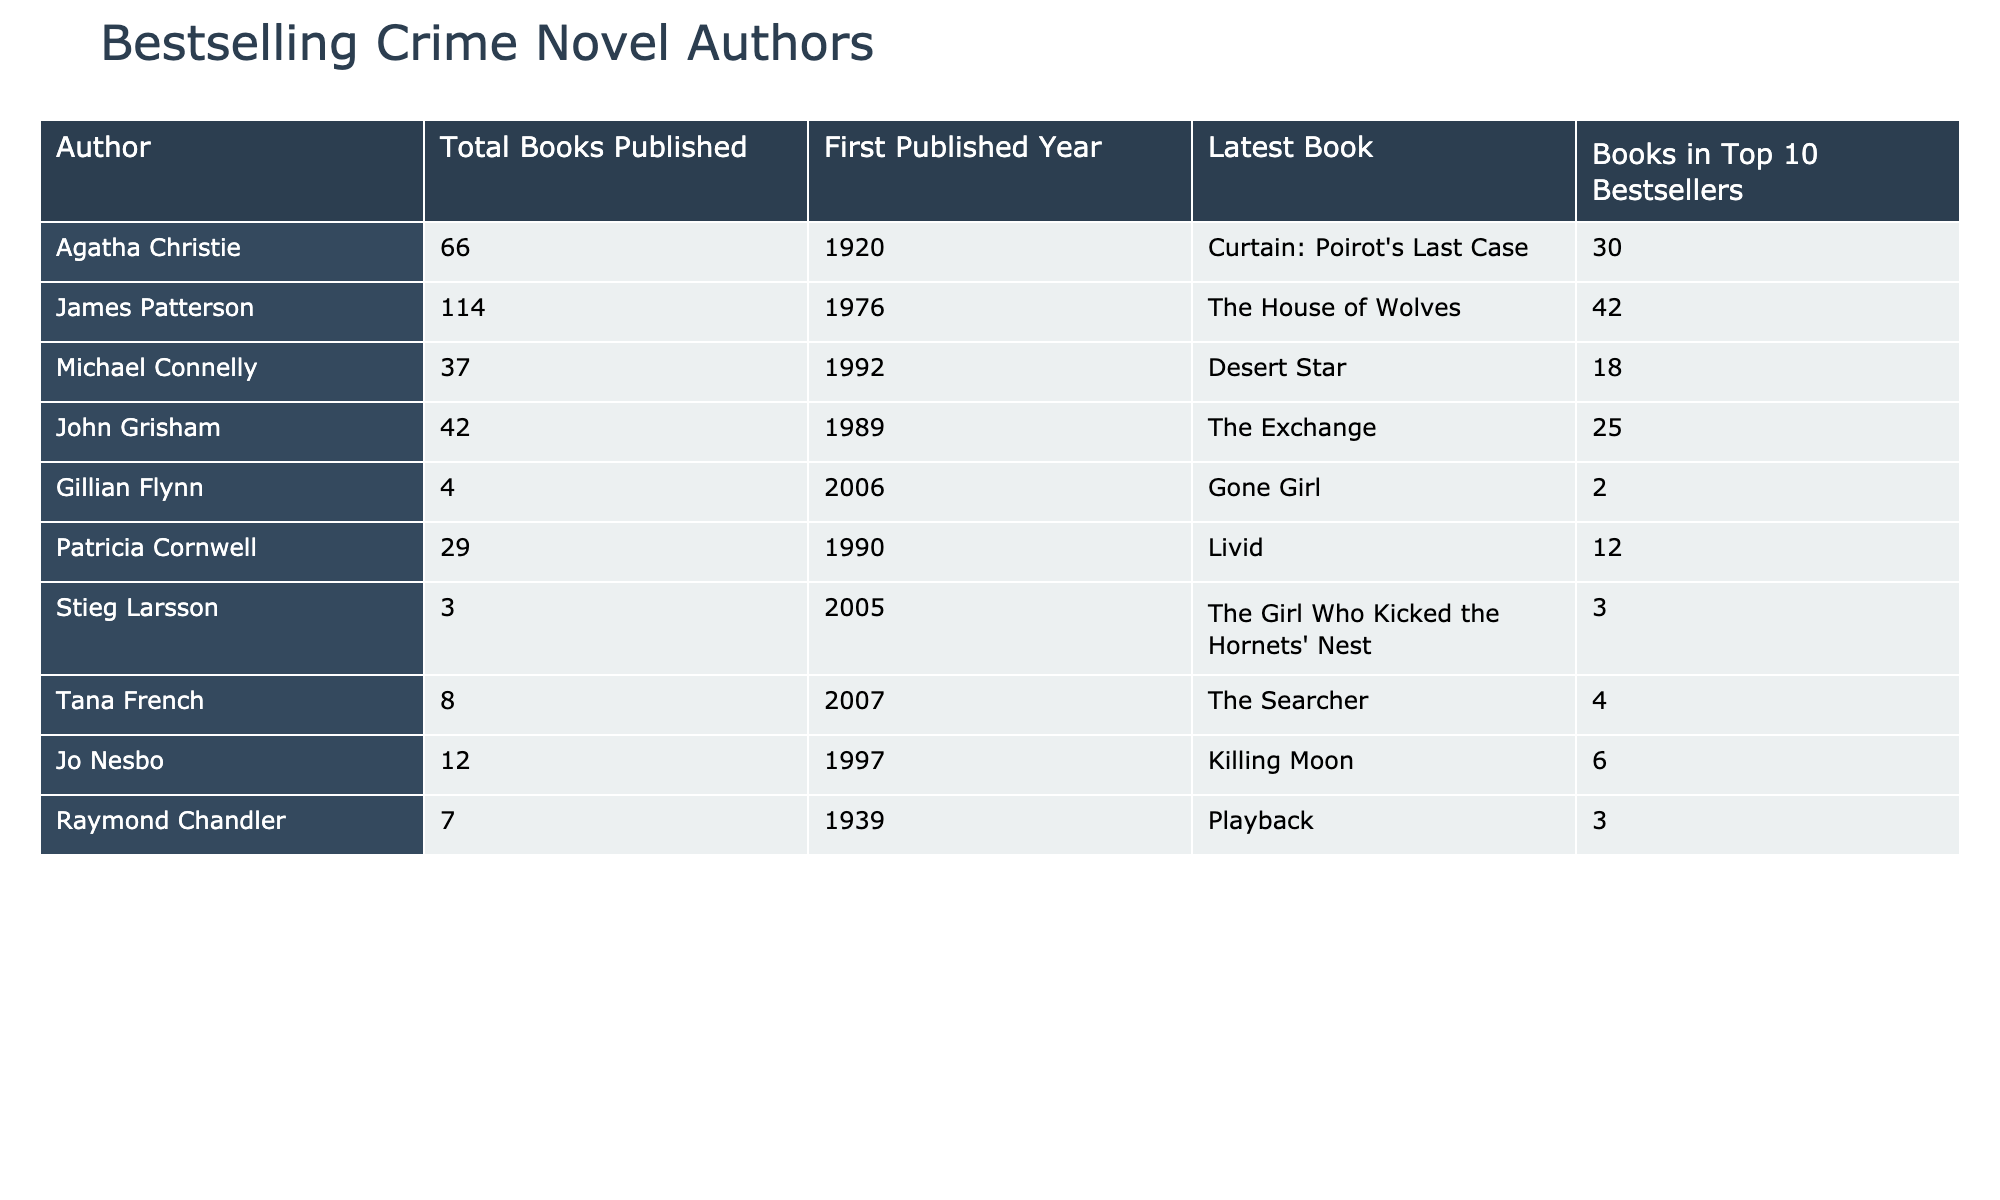What is the total number of books published by James Patterson? The table clearly shows that James Patterson has published a total of 114 books.
Answer: 114 Who is the author with the most books in the Top 10 Bestsellers? By examining the column for the number of books in the Top 10 Bestsellers, James Patterson has the highest count at 42.
Answer: James Patterson How many authors have published fewer than 10 books? Looking at the data, Gillian Flynn (4), Stieg Larsson (3), Tana French (8), and Jo Nesbo (12) fit this criteria, summing to 4 authors in total.
Answer: 4 What is the average number of books published by the authors listed? The sum of total books published is 66 + 114 + 37 + 42 + 4 + 29 + 3 + 8 + 12 + 7 = 322. There are 10 authors, so the average is 322/10 = 32.2.
Answer: 32.2 Did any author start publishing before 1950 and have at least 30 books in the Top 10 Bestsellers? Checking the first published year, Agatha Christie and Raymond Chandler both started before 1950, but only Agatha Christie has 30 books in the Top 10, so the answer is yes.
Answer: Yes How many more books does Michael Connelly have compared to Gillian Flynn? Michael Connelly has published 37 books, while Gillian Flynn has published 4 books. The difference is 37 - 4 = 33.
Answer: 33 Which author has the most recent publication year? The latest publication year listed is 2023 for Michael Connelly (as implied by the latest book title), making him the author with the most recent year of publication.
Answer: Michael Connelly Is it true that all authors have published at least 3 books? Assessing the minimum published books per author, both Gillian Flynn (4) and Stieg Larsson (3) confirm that all authors have indeed published at least 3 books.
Answer: Yes What is the difference in the number of books published between the author with the most books and the one with the least? James Patterson has 114 books while Stieg Larsson has the least with 3, so the difference is 114 - 3 = 111.
Answer: 111 Which author published their first book in the year 1990? The table indicates that Patricia Cornwell published her first book in 1990, as listed in the First Published Year column.
Answer: Patricia Cornwell 